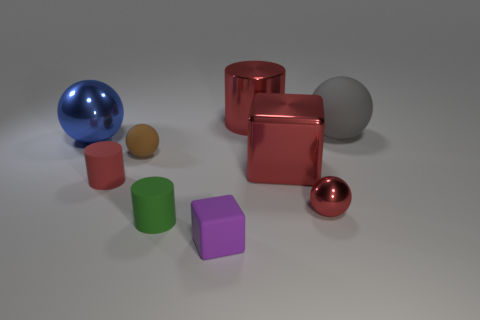How many objects are either big blue balls or things that are on the left side of the small cube?
Keep it short and to the point. 4. What material is the gray thing that is the same size as the blue shiny object?
Ensure brevity in your answer.  Rubber. There is a ball that is behind the brown thing and on the left side of the gray sphere; what material is it made of?
Offer a very short reply. Metal. There is a big ball that is to the left of the tiny purple object; are there any matte things that are behind it?
Offer a terse response. Yes. There is a thing that is to the left of the gray ball and behind the blue sphere; what size is it?
Your response must be concise. Large. How many red things are small metallic balls or large cylinders?
Your response must be concise. 2. There is a shiny thing that is the same size as the red rubber cylinder; what is its shape?
Make the answer very short. Sphere. How many other things are there of the same color as the rubber cube?
Make the answer very short. 0. How big is the red matte thing on the left side of the red object behind the large matte ball?
Give a very brief answer. Small. Does the large ball that is right of the tiny purple object have the same material as the red cube?
Offer a terse response. No. 